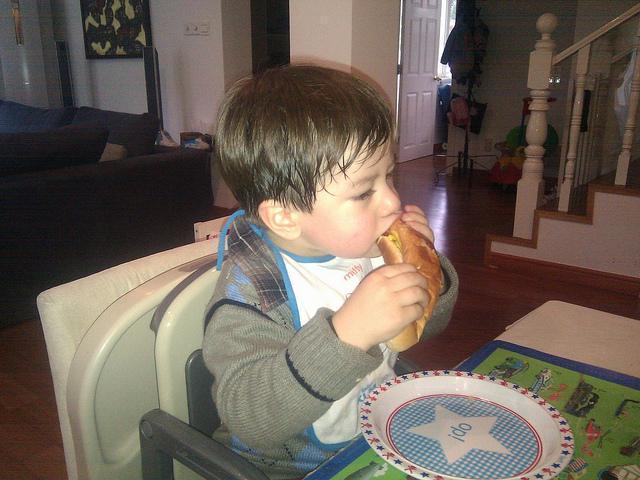How many sandwiches can you see?
Give a very brief answer. 1. How many elephants can you see it's trunk?
Give a very brief answer. 0. 